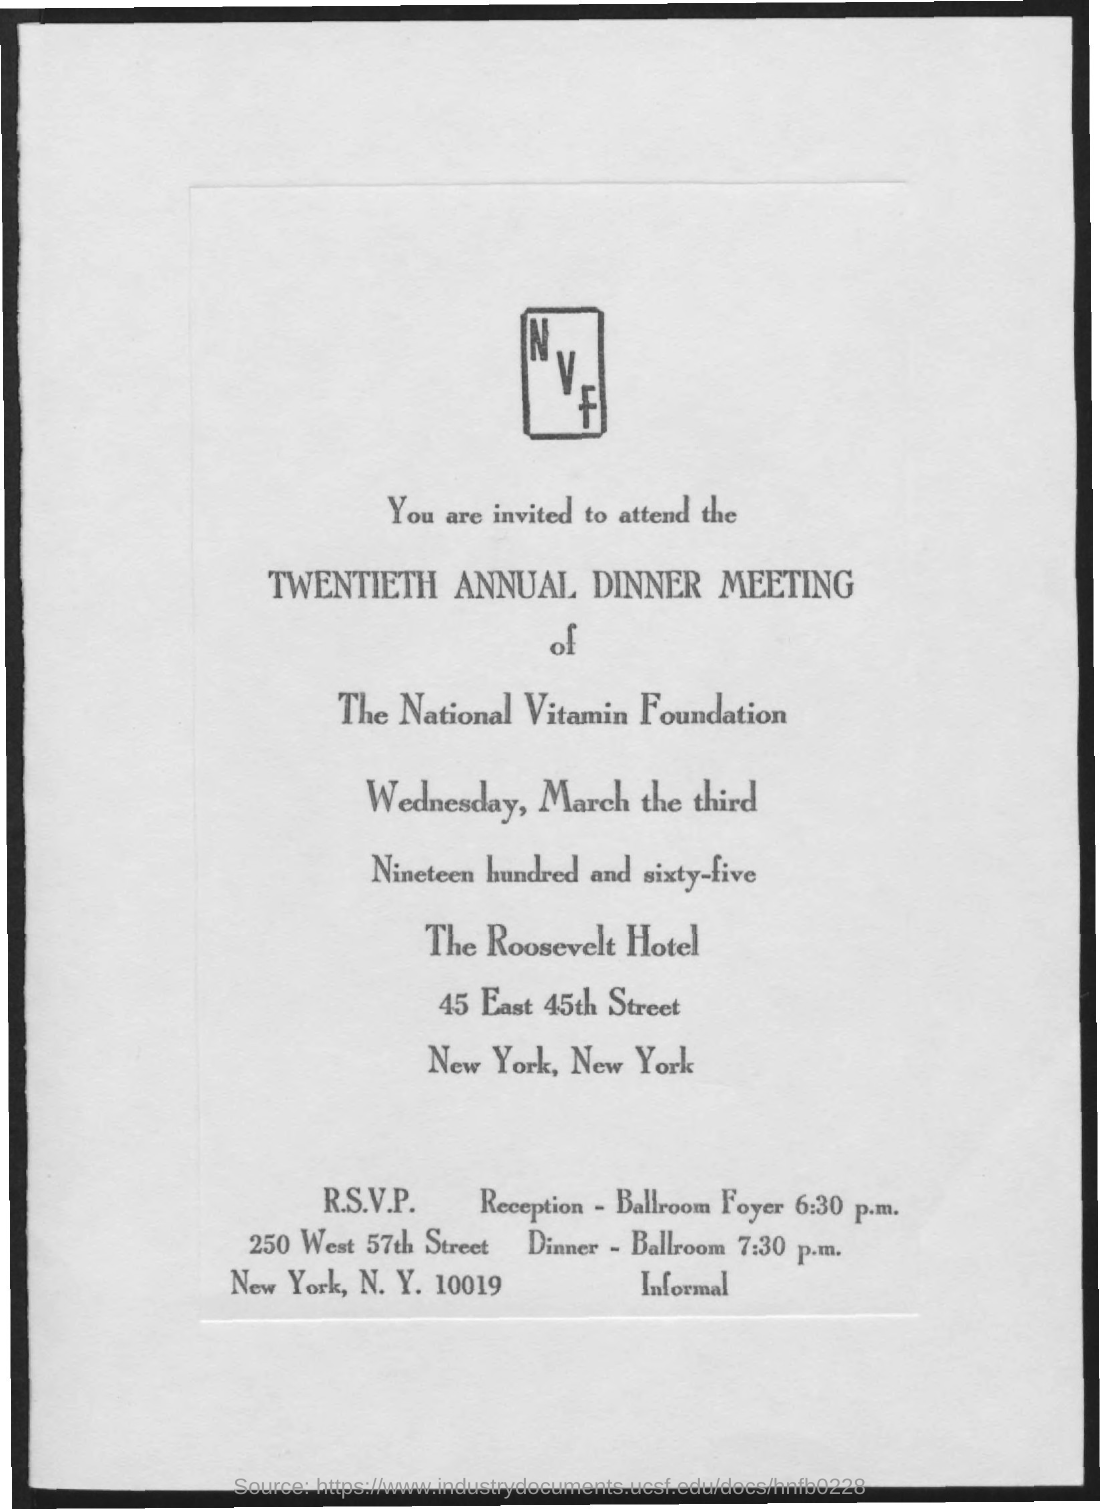What is the invitation for?
Your answer should be very brief. Twentieth annual dinner meeting. Where is the reception?
Your response must be concise. Ballroom foyer. Where is the Dinner?
Your response must be concise. Ballroom. 